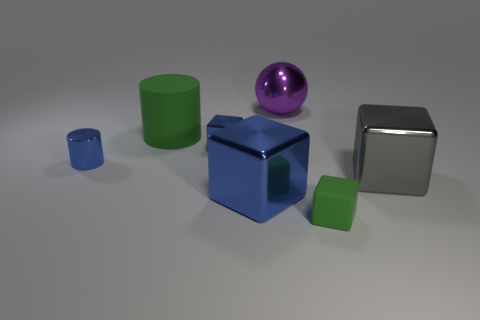Add 3 big matte blocks. How many objects exist? 10 Subtract all balls. How many objects are left? 6 Subtract all tiny yellow matte cubes. Subtract all blue shiny blocks. How many objects are left? 5 Add 1 large balls. How many large balls are left? 2 Add 5 big blue rubber objects. How many big blue rubber objects exist? 5 Subtract 0 red balls. How many objects are left? 7 